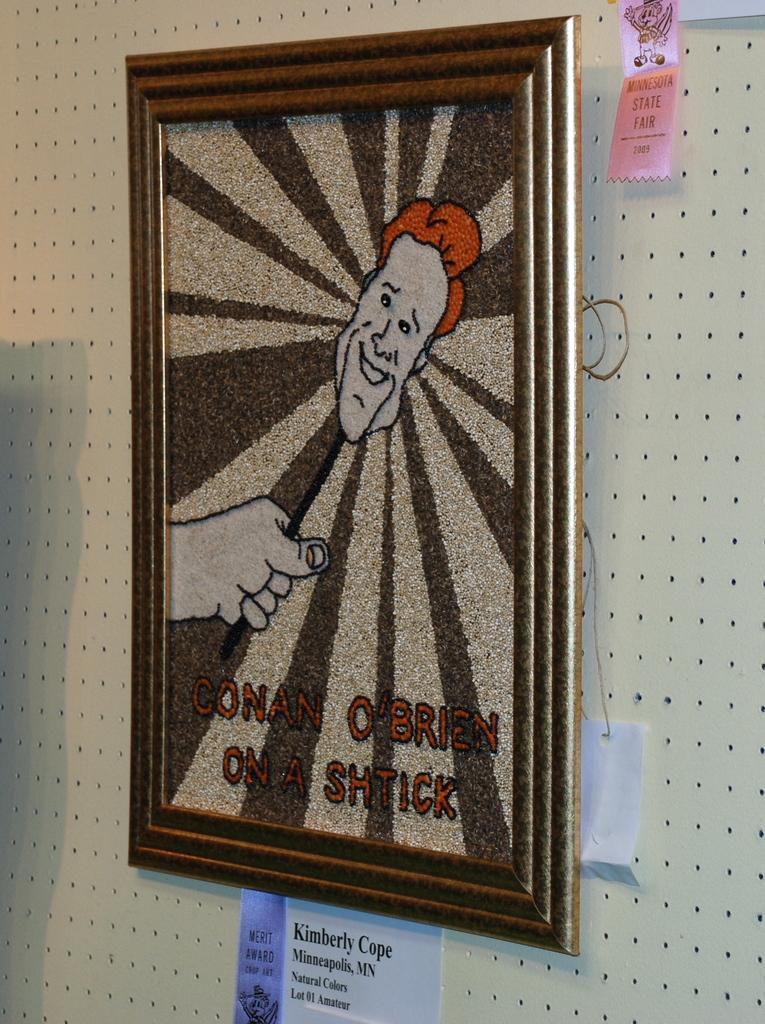<image>
Relay a brief, clear account of the picture shown. A picture of conan o' brien on a shtick is hanging on a wall. 